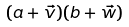Convert formula to latex. <formula><loc_0><loc_0><loc_500><loc_500>( a + { \vec { v } } ) ( b + { \vec { w } } )</formula> 